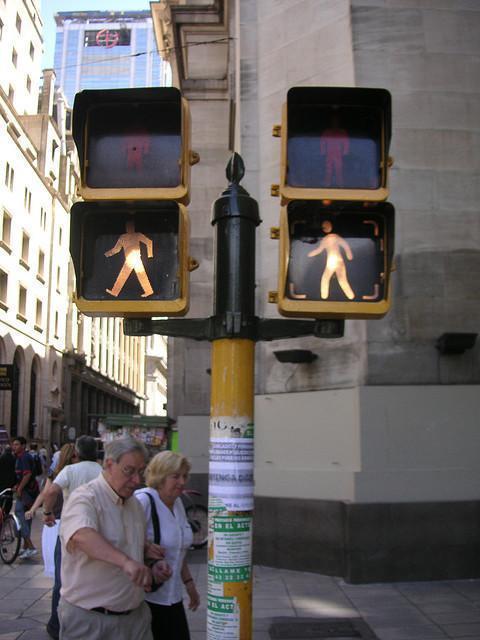What is the traffic light permitting?
From the following set of four choices, select the accurate answer to respond to the question.
Options: Jaywalking, parking, crossing, driving. Crossing. 